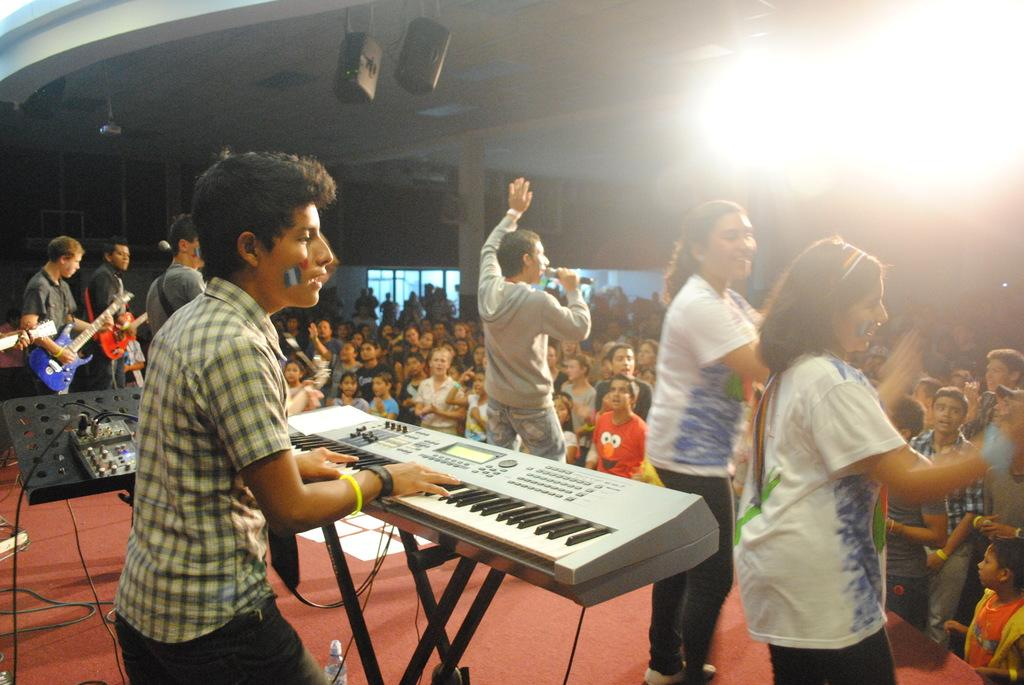How many people are in the image? There is a group of people in the image. What activity is one person engaged in? One person is playing the piano in the image. What type of punishment is being administered to the person playing the piano in the image? There is no indication of punishment in the image; the person is simply playing the piano. What kind of nut can be seen growing on the branch in the image? There is no branch or nut present in the image. 